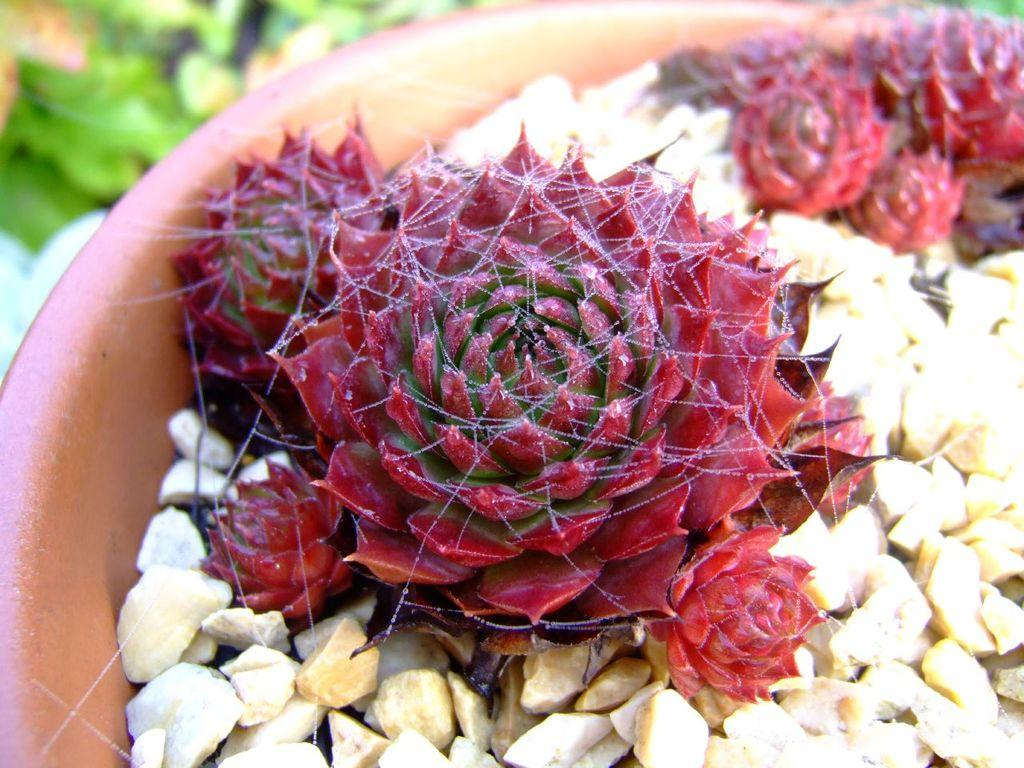What color are the plants in the flower pot? The plants in the flower pot are red. What else can be found in the flower pot besides the plants? There are stones in the flower pot. Can you describe the blurred part of the image? The blurred part of the image is in green color. What type of record can be seen in the cemetery in the image? There is no cemetery or record present in the image; it features a flower pot with red plants and stones. 